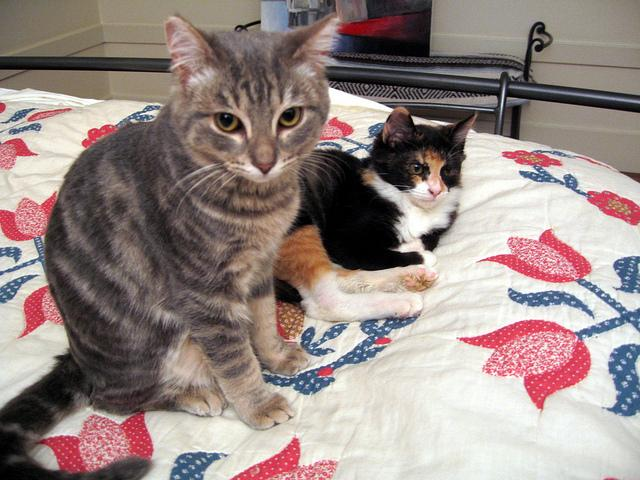What is the difference of these two cats? Please explain your reasoning. breed. One cat is gray and bigger while the other cat is black with brown and smaller indicated that they are not the same species. 